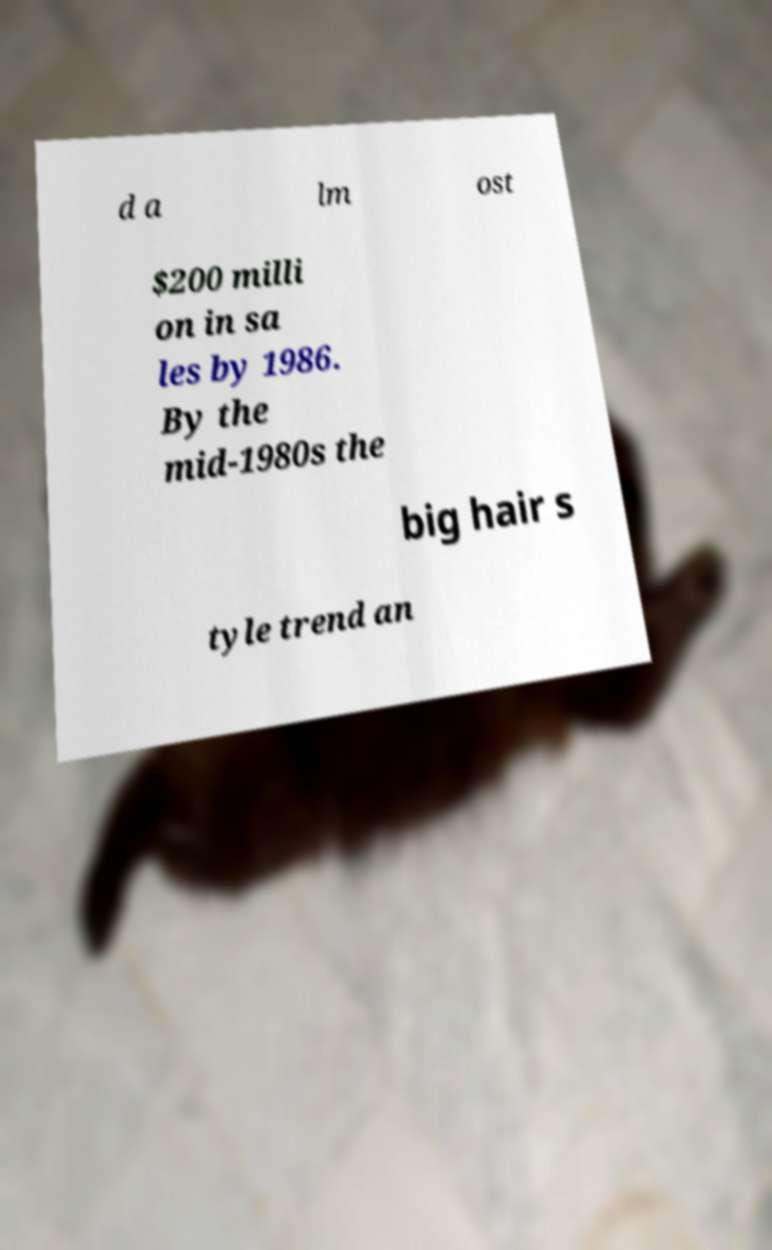Could you extract and type out the text from this image? d a lm ost $200 milli on in sa les by 1986. By the mid-1980s the big hair s tyle trend an 